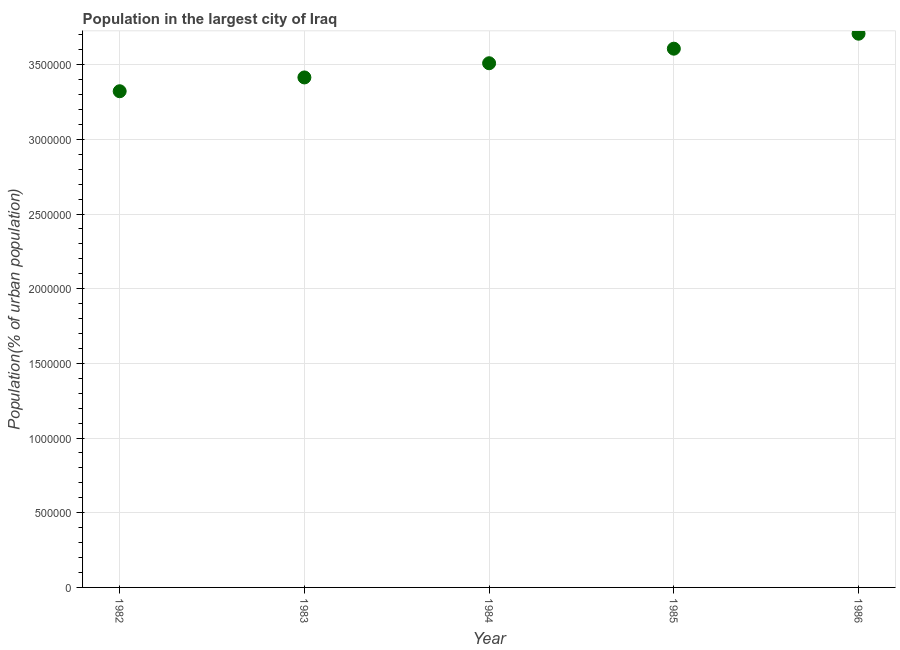What is the population in largest city in 1984?
Offer a terse response. 3.51e+06. Across all years, what is the maximum population in largest city?
Offer a very short reply. 3.71e+06. Across all years, what is the minimum population in largest city?
Your response must be concise. 3.32e+06. What is the sum of the population in largest city?
Keep it short and to the point. 1.76e+07. What is the difference between the population in largest city in 1984 and 1985?
Give a very brief answer. -9.74e+04. What is the average population in largest city per year?
Your answer should be very brief. 3.51e+06. What is the median population in largest city?
Offer a terse response. 3.51e+06. In how many years, is the population in largest city greater than 1800000 %?
Your answer should be compact. 5. What is the ratio of the population in largest city in 1982 to that in 1985?
Provide a short and direct response. 0.92. Is the population in largest city in 1983 less than that in 1984?
Provide a short and direct response. Yes. Is the difference between the population in largest city in 1983 and 1985 greater than the difference between any two years?
Offer a very short reply. No. What is the difference between the highest and the second highest population in largest city?
Offer a very short reply. 1.00e+05. Is the sum of the population in largest city in 1984 and 1985 greater than the maximum population in largest city across all years?
Offer a very short reply. Yes. What is the difference between the highest and the lowest population in largest city?
Ensure brevity in your answer.  3.85e+05. In how many years, is the population in largest city greater than the average population in largest city taken over all years?
Make the answer very short. 2. Does the population in largest city monotonically increase over the years?
Provide a succinct answer. Yes. How many dotlines are there?
Your answer should be very brief. 1. How many years are there in the graph?
Provide a succinct answer. 5. What is the difference between two consecutive major ticks on the Y-axis?
Your answer should be compact. 5.00e+05. Does the graph contain any zero values?
Your answer should be compact. No. What is the title of the graph?
Your response must be concise. Population in the largest city of Iraq. What is the label or title of the X-axis?
Offer a terse response. Year. What is the label or title of the Y-axis?
Your answer should be very brief. Population(% of urban population). What is the Population(% of urban population) in 1982?
Your answer should be very brief. 3.32e+06. What is the Population(% of urban population) in 1983?
Provide a short and direct response. 3.41e+06. What is the Population(% of urban population) in 1984?
Provide a succinct answer. 3.51e+06. What is the Population(% of urban population) in 1985?
Your answer should be compact. 3.61e+06. What is the Population(% of urban population) in 1986?
Provide a succinct answer. 3.71e+06. What is the difference between the Population(% of urban population) in 1982 and 1983?
Give a very brief answer. -9.24e+04. What is the difference between the Population(% of urban population) in 1982 and 1984?
Offer a terse response. -1.87e+05. What is the difference between the Population(% of urban population) in 1982 and 1985?
Make the answer very short. -2.85e+05. What is the difference between the Population(% of urban population) in 1982 and 1986?
Offer a terse response. -3.85e+05. What is the difference between the Population(% of urban population) in 1983 and 1984?
Make the answer very short. -9.51e+04. What is the difference between the Population(% of urban population) in 1983 and 1985?
Provide a succinct answer. -1.93e+05. What is the difference between the Population(% of urban population) in 1983 and 1986?
Your answer should be compact. -2.93e+05. What is the difference between the Population(% of urban population) in 1984 and 1985?
Ensure brevity in your answer.  -9.74e+04. What is the difference between the Population(% of urban population) in 1984 and 1986?
Your response must be concise. -1.98e+05. What is the difference between the Population(% of urban population) in 1985 and 1986?
Make the answer very short. -1.00e+05. What is the ratio of the Population(% of urban population) in 1982 to that in 1983?
Your answer should be compact. 0.97. What is the ratio of the Population(% of urban population) in 1982 to that in 1984?
Ensure brevity in your answer.  0.95. What is the ratio of the Population(% of urban population) in 1982 to that in 1985?
Offer a very short reply. 0.92. What is the ratio of the Population(% of urban population) in 1982 to that in 1986?
Your response must be concise. 0.9. What is the ratio of the Population(% of urban population) in 1983 to that in 1985?
Offer a very short reply. 0.95. What is the ratio of the Population(% of urban population) in 1983 to that in 1986?
Provide a short and direct response. 0.92. What is the ratio of the Population(% of urban population) in 1984 to that in 1986?
Keep it short and to the point. 0.95. What is the ratio of the Population(% of urban population) in 1985 to that in 1986?
Make the answer very short. 0.97. 